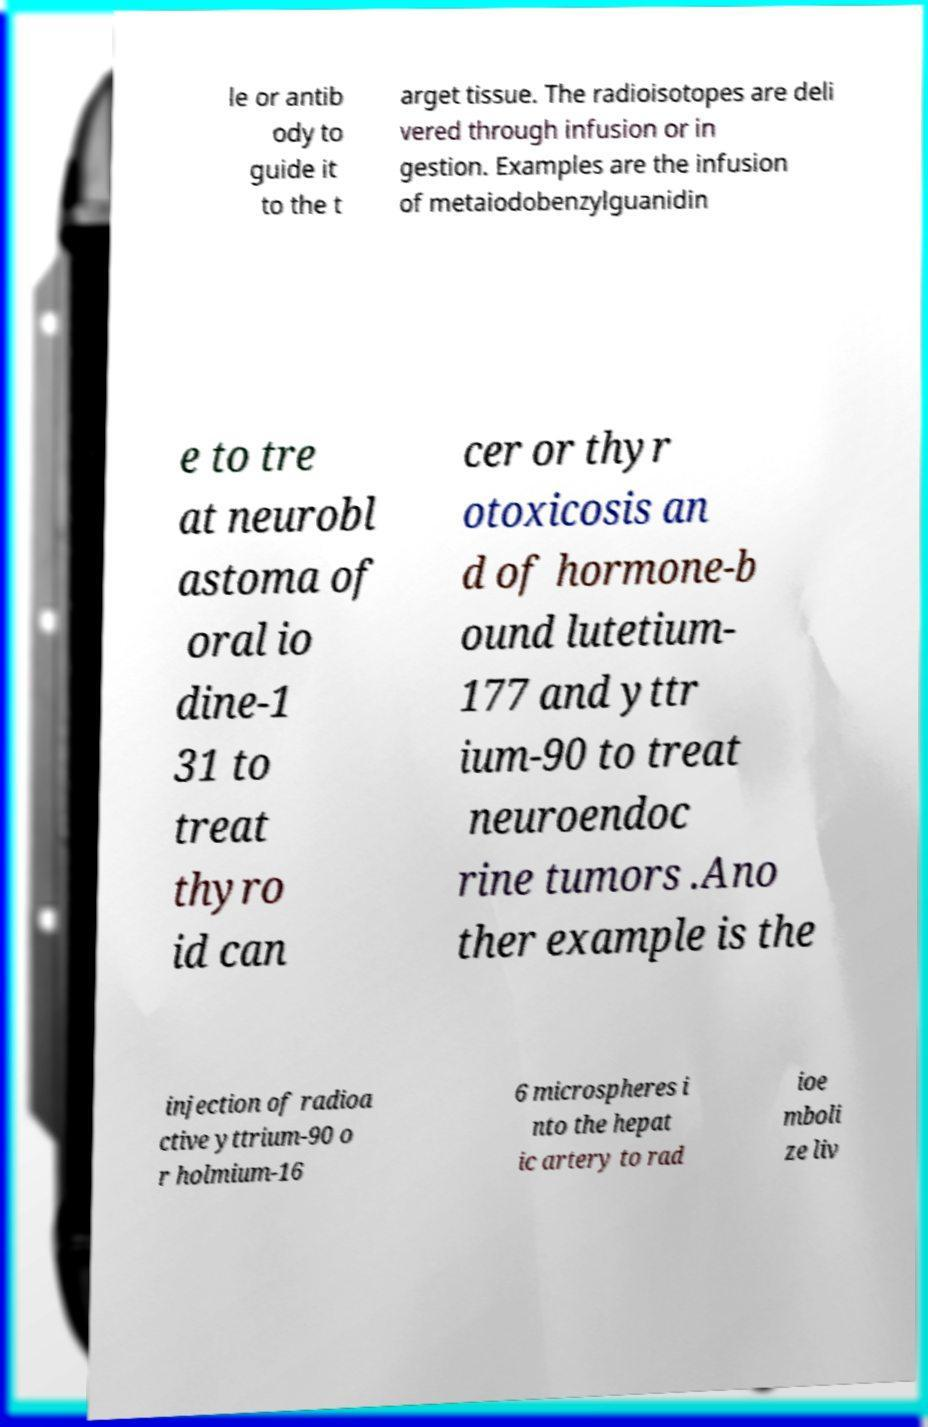I need the written content from this picture converted into text. Can you do that? le or antib ody to guide it to the t arget tissue. The radioisotopes are deli vered through infusion or in gestion. Examples are the infusion of metaiodobenzylguanidin e to tre at neurobl astoma of oral io dine-1 31 to treat thyro id can cer or thyr otoxicosis an d of hormone-b ound lutetium- 177 and yttr ium-90 to treat neuroendoc rine tumors .Ano ther example is the injection of radioa ctive yttrium-90 o r holmium-16 6 microspheres i nto the hepat ic artery to rad ioe mboli ze liv 